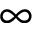Convert formula to latex. <formula><loc_0><loc_0><loc_500><loc_500>\infty</formula> 